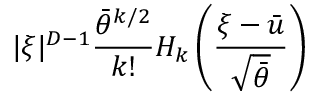<formula> <loc_0><loc_0><loc_500><loc_500>| \xi | ^ { D - 1 } \frac { \bar { \theta } ^ { k / 2 } } { k ! } H _ { k } \left ( \frac { \xi - \bar { u } } { \sqrt { \bar { \theta } } } \right )</formula> 